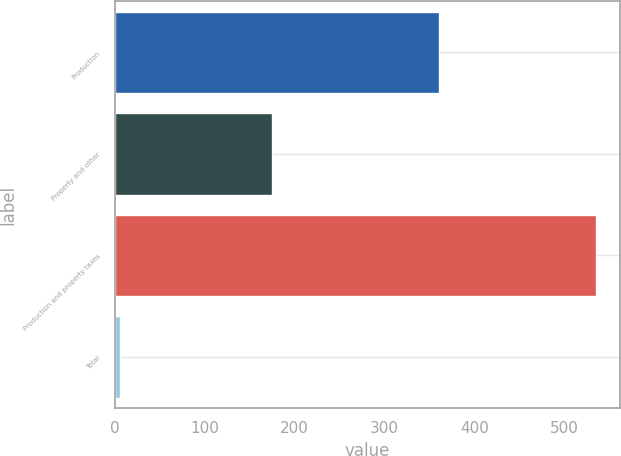Convert chart. <chart><loc_0><loc_0><loc_500><loc_500><bar_chart><fcel>Production<fcel>Property and other<fcel>Production and property taxes<fcel>Total<nl><fcel>360<fcel>175<fcel>535<fcel>5.4<nl></chart> 